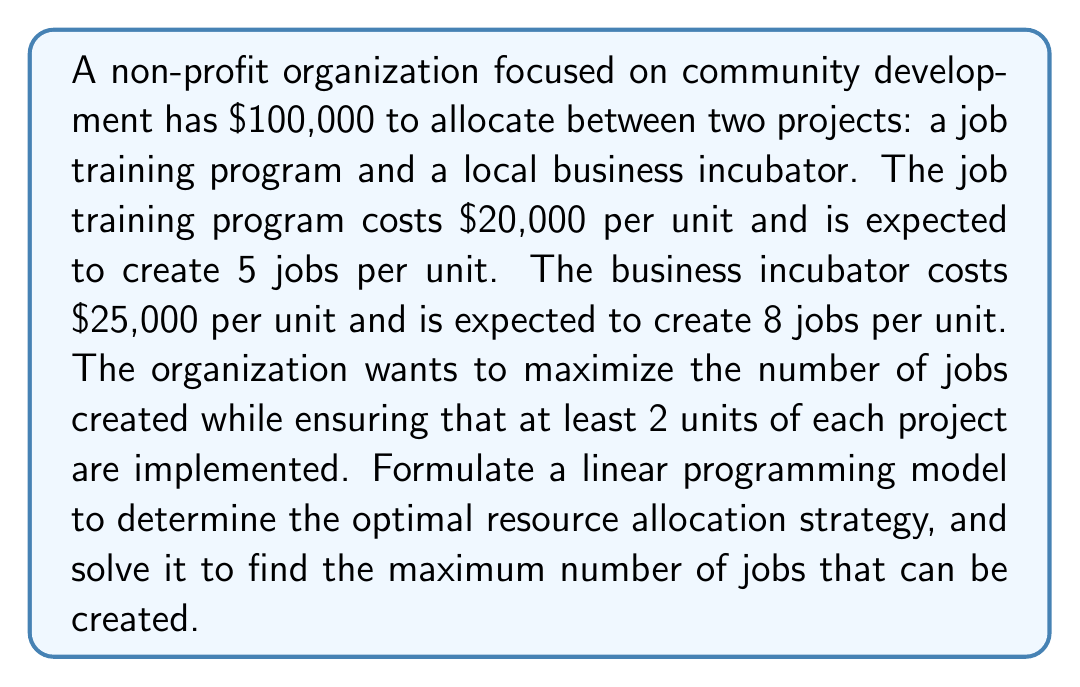Teach me how to tackle this problem. Let's approach this step-by-step:

1. Define variables:
   Let $x$ = number of job training program units
   Let $y$ = number of business incubator units

2. Objective function:
   Maximize $Z = 5x + 8y$ (total jobs created)

3. Constraints:
   a) Budget constraint: $20000x + 25000y \leq 100000$
   b) Minimum units for job training: $x \geq 2$
   c) Minimum units for business incubator: $y \geq 2$
   d) Non-negativity: $x \geq 0$, $y \geq 0$

4. Simplify the budget constraint:
   $20x + 25y \leq 100$

5. The linear programming model:

   Maximize $Z = 5x + 8y$
   Subject to:
   $20x + 25y \leq 100$
   $x \geq 2$
   $y \geq 2$
   $x, y \geq 0$

6. Solve graphically or using the simplex method:
   - The feasible region is bounded by the lines $20x + 25y = 100$, $x = 2$, and $y = 2$
   - The optimal solution will be at one of the corner points of this region

7. Corner points:
   (2, 2), (2, 3.84), (3, 2), (2.6, 3.28)

8. Evaluate the objective function at each point:
   (2, 2): $Z = 5(2) + 8(2) = 26$
   (2, 3.84): $Z = 5(2) + 8(3.84) = 40.72$
   (3, 2): $Z = 5(3) + 8(2) = 31$
   (2.6, 3.28): $Z = 5(2.6) + 8(3.28) = 39.24$

9. The maximum value is at (2, 3.84), but we need integer solutions.
   Rounding down, we get (2, 3) as our optimal integer solution.
Answer: The optimal resource allocation strategy is to implement 2 units of the job training program and 3 units of the business incubator. This will create a maximum of $5(2) + 8(3) = 34$ jobs while satisfying all constraints. 